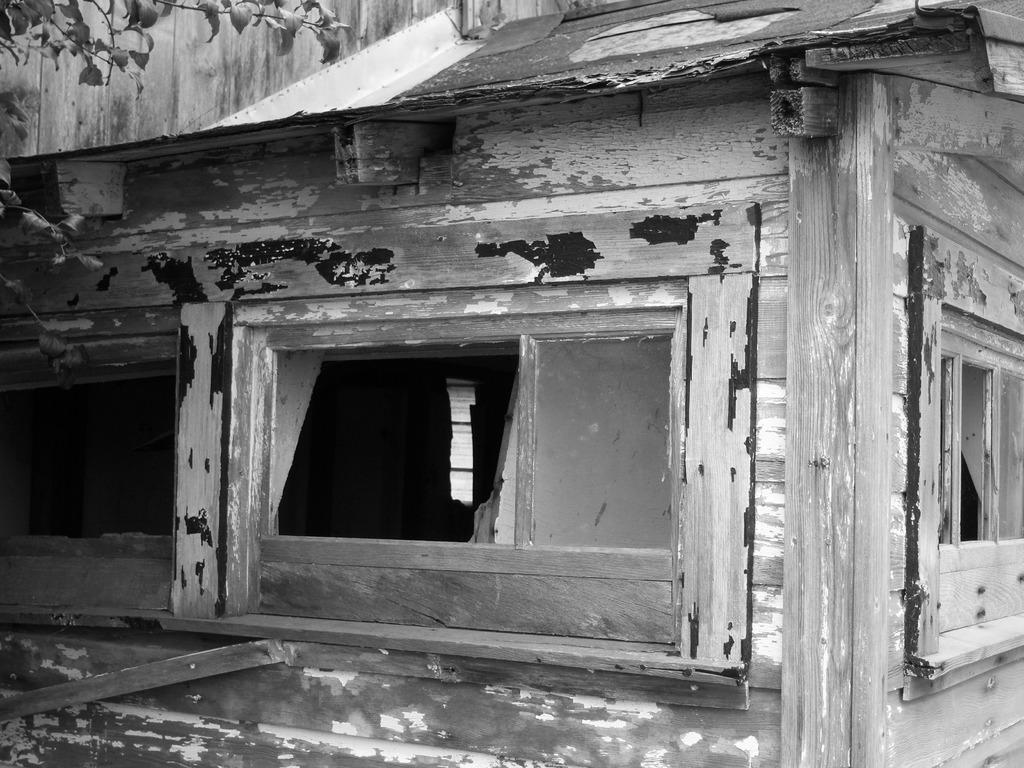What is the color scheme of the image? The image is black and white. What can be seen in the foreground of the image? There are windows in the foreground of the image. What type of house do the windows belong to? The windows belong to a wooden house. What is visible at the top of the image? There are leaves visible at the top of the image. How are the leaves connected to the stem? The leaves are attached to a stem. Can you tell me where my aunt is sitting in the image? There is no information about your aunt in the image, as it only features windows, a wooden house, and leaves. 